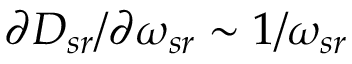<formula> <loc_0><loc_0><loc_500><loc_500>\partial D _ { s r } / \partial \omega _ { s r } \sim 1 / \omega _ { s r }</formula> 